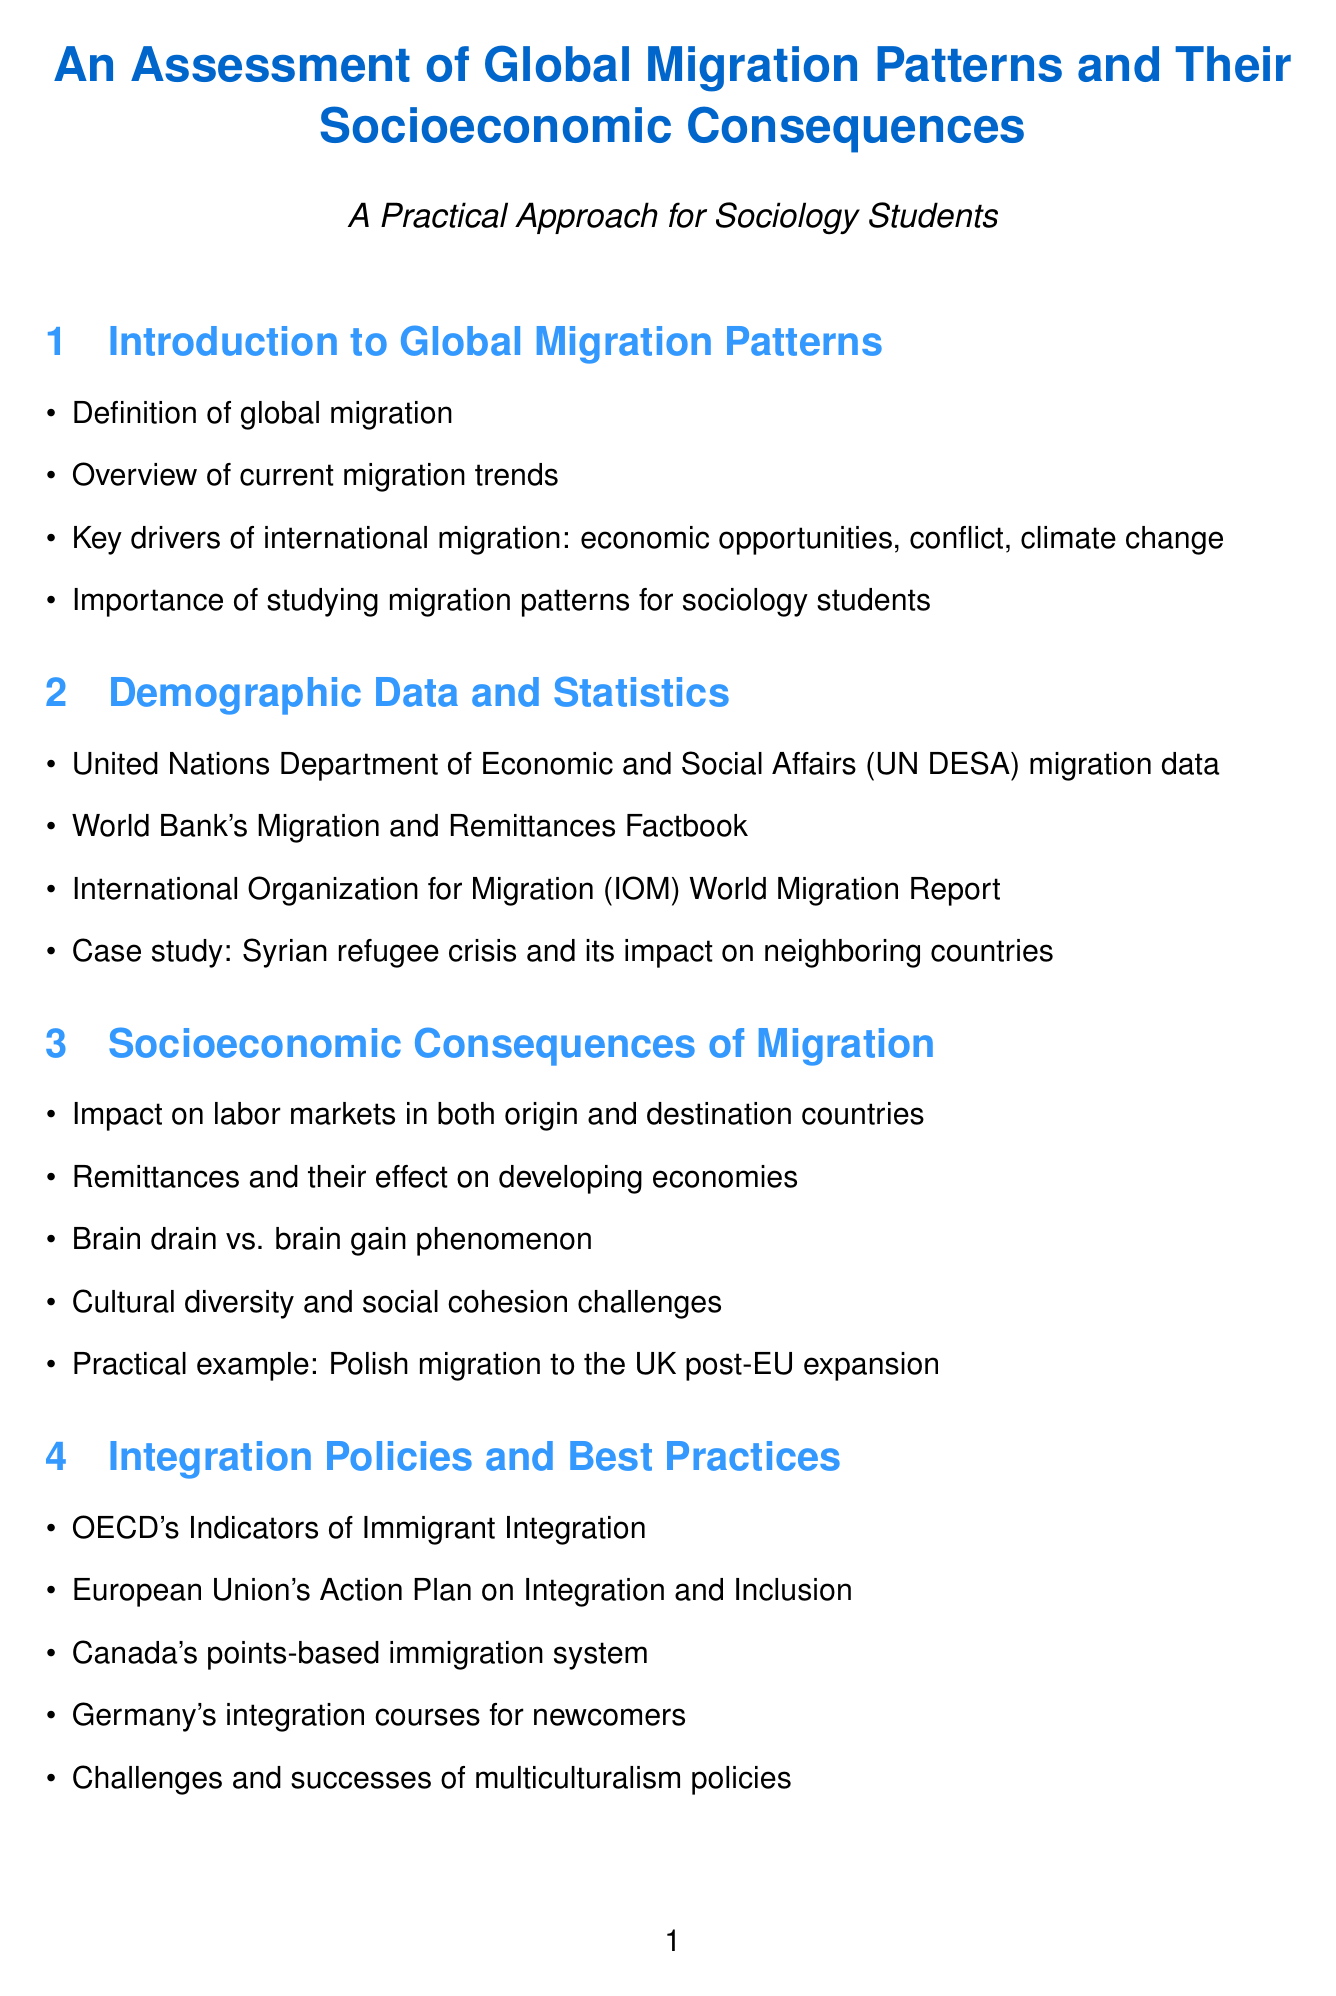What is the title of the report? The title of the report is clearly stated at the beginning of the document.
Answer: An Assessment of Global Migration Patterns and Their Socioeconomic Consequences What key drivers of international migration are mentioned? The report lists key drivers of migration in the introduction section.
Answer: economic opportunities, conflict, climate change What case study is referenced in the demographic data section? A specific case study is highlighted to illustrate the impact of migration in the demographic data section.
Answer: Syrian refugee crisis and its impact on neighboring countries Which organization published the "World Migration Report" in 2022? The document provides the publisher information for key sources used.
Answer: International Organization for Migration What is the focus of the practical assignment titled "Field Research: Local Migration Impact"? The document describes the purpose of each practical assignment in detail.
Answer: Conduct interviews with local government officials and migrant community leaders What phenomenon is contrasted in the socioeconomic consequences section? The report discusses broader concepts and effects of migration in this section.
Answer: Brain drain vs. brain gain phenomenon What action plan is outlined under integration policies? Integration policies include specific plans mentioned in the relevant section.
Answer: European Union's Action Plan on Integration and Inclusion What was the focus of the migration data analysis project assignment? Each practical assignment's objective is detailed in the report for clear understanding.
Answer: Analyze migration data from the UN DESA database 